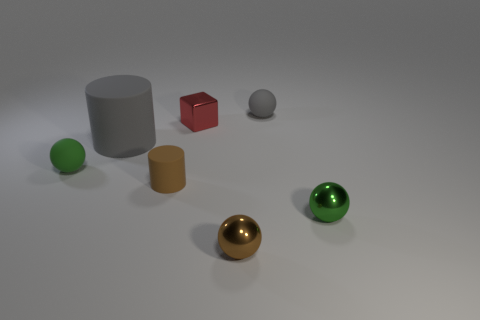What shape is the other object that is the same color as the large object?
Make the answer very short. Sphere. There is a metallic ball that is on the right side of the brown sphere; does it have the same size as the tiny matte cylinder?
Your response must be concise. Yes. Are there an equal number of large objects that are in front of the gray cylinder and brown spheres?
Your response must be concise. No. What number of things are either green spheres to the right of the tiny cylinder or big cylinders?
Your answer should be very brief. 2. What is the shape of the tiny object that is left of the brown metal sphere and to the right of the tiny brown cylinder?
Your answer should be very brief. Cube. How many things are either gray matte objects that are to the left of the tiny red thing or balls in front of the tiny brown cylinder?
Give a very brief answer. 3. What number of other things are there of the same size as the brown matte object?
Ensure brevity in your answer.  5. Is the color of the tiny matte sphere that is to the left of the large gray object the same as the big rubber thing?
Your response must be concise. No. How big is the object that is both right of the red block and behind the big cylinder?
Your answer should be compact. Small. How many small objects are either green shiny objects or blocks?
Offer a terse response. 2. 